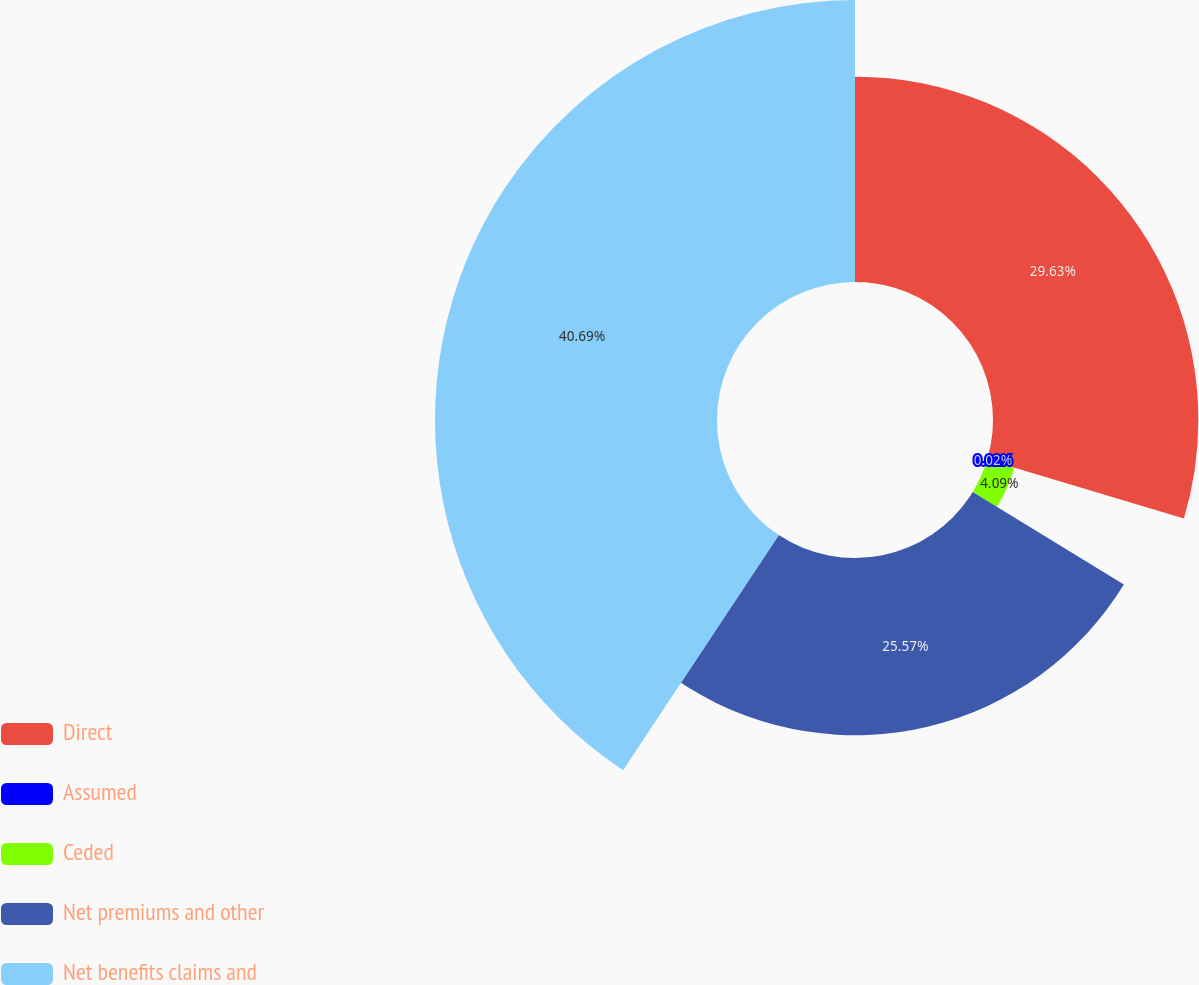Convert chart. <chart><loc_0><loc_0><loc_500><loc_500><pie_chart><fcel>Direct<fcel>Assumed<fcel>Ceded<fcel>Net premiums and other<fcel>Net benefits claims and<nl><fcel>29.63%<fcel>0.02%<fcel>4.09%<fcel>25.57%<fcel>40.69%<nl></chart> 